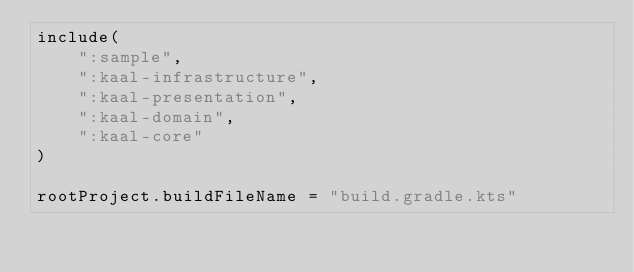Convert code to text. <code><loc_0><loc_0><loc_500><loc_500><_Kotlin_>include(
    ":sample",
    ":kaal-infrastructure",
    ":kaal-presentation",
    ":kaal-domain",
    ":kaal-core"
)

rootProject.buildFileName = "build.gradle.kts"
</code> 